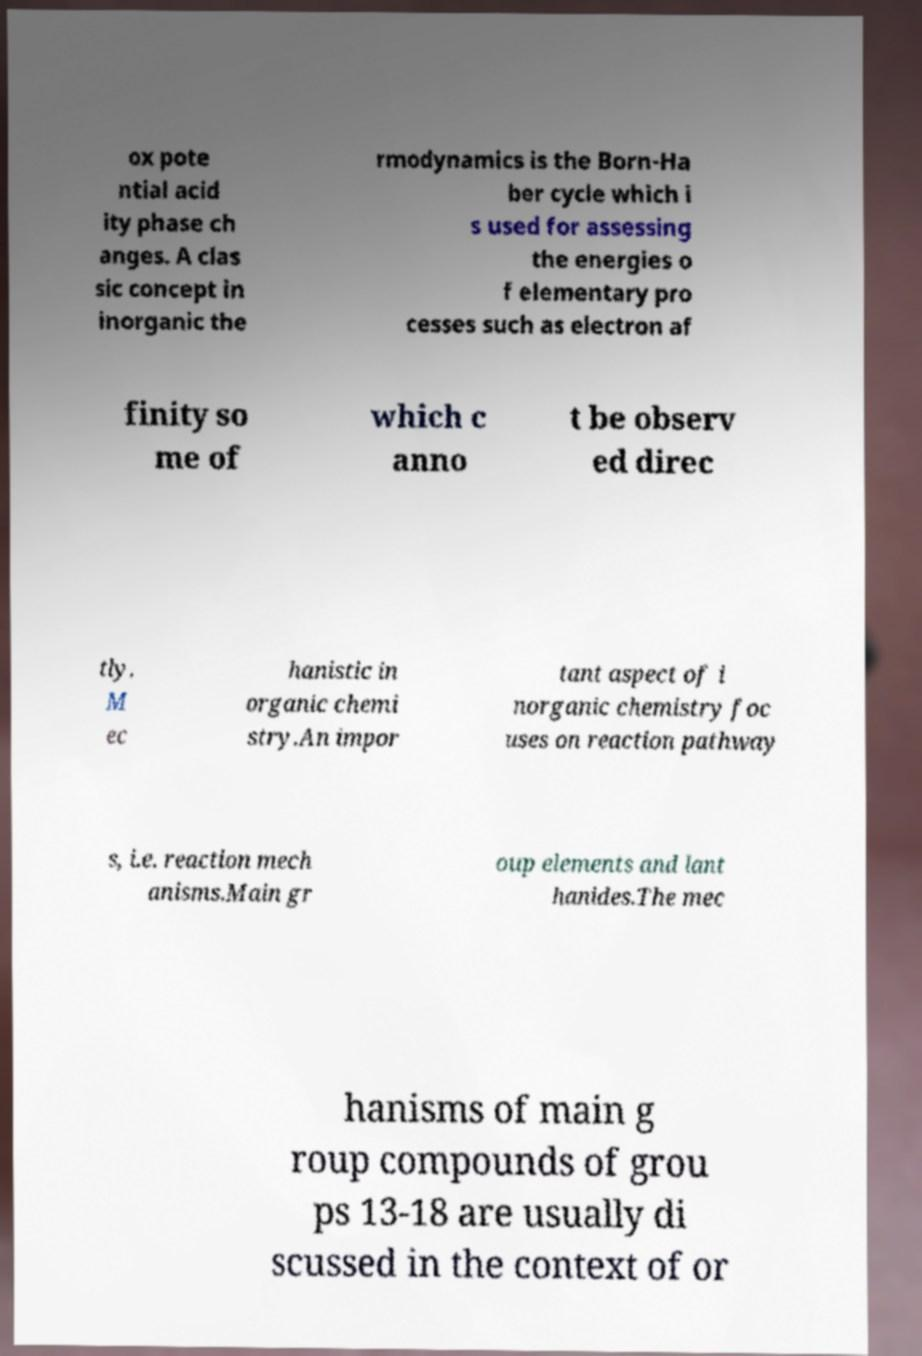Please read and relay the text visible in this image. What does it say? ox pote ntial acid ity phase ch anges. A clas sic concept in inorganic the rmodynamics is the Born-Ha ber cycle which i s used for assessing the energies o f elementary pro cesses such as electron af finity so me of which c anno t be observ ed direc tly. M ec hanistic in organic chemi stry.An impor tant aspect of i norganic chemistry foc uses on reaction pathway s, i.e. reaction mech anisms.Main gr oup elements and lant hanides.The mec hanisms of main g roup compounds of grou ps 13-18 are usually di scussed in the context of or 